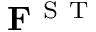<formula> <loc_0><loc_0><loc_500><loc_500>F ^ { S T }</formula> 